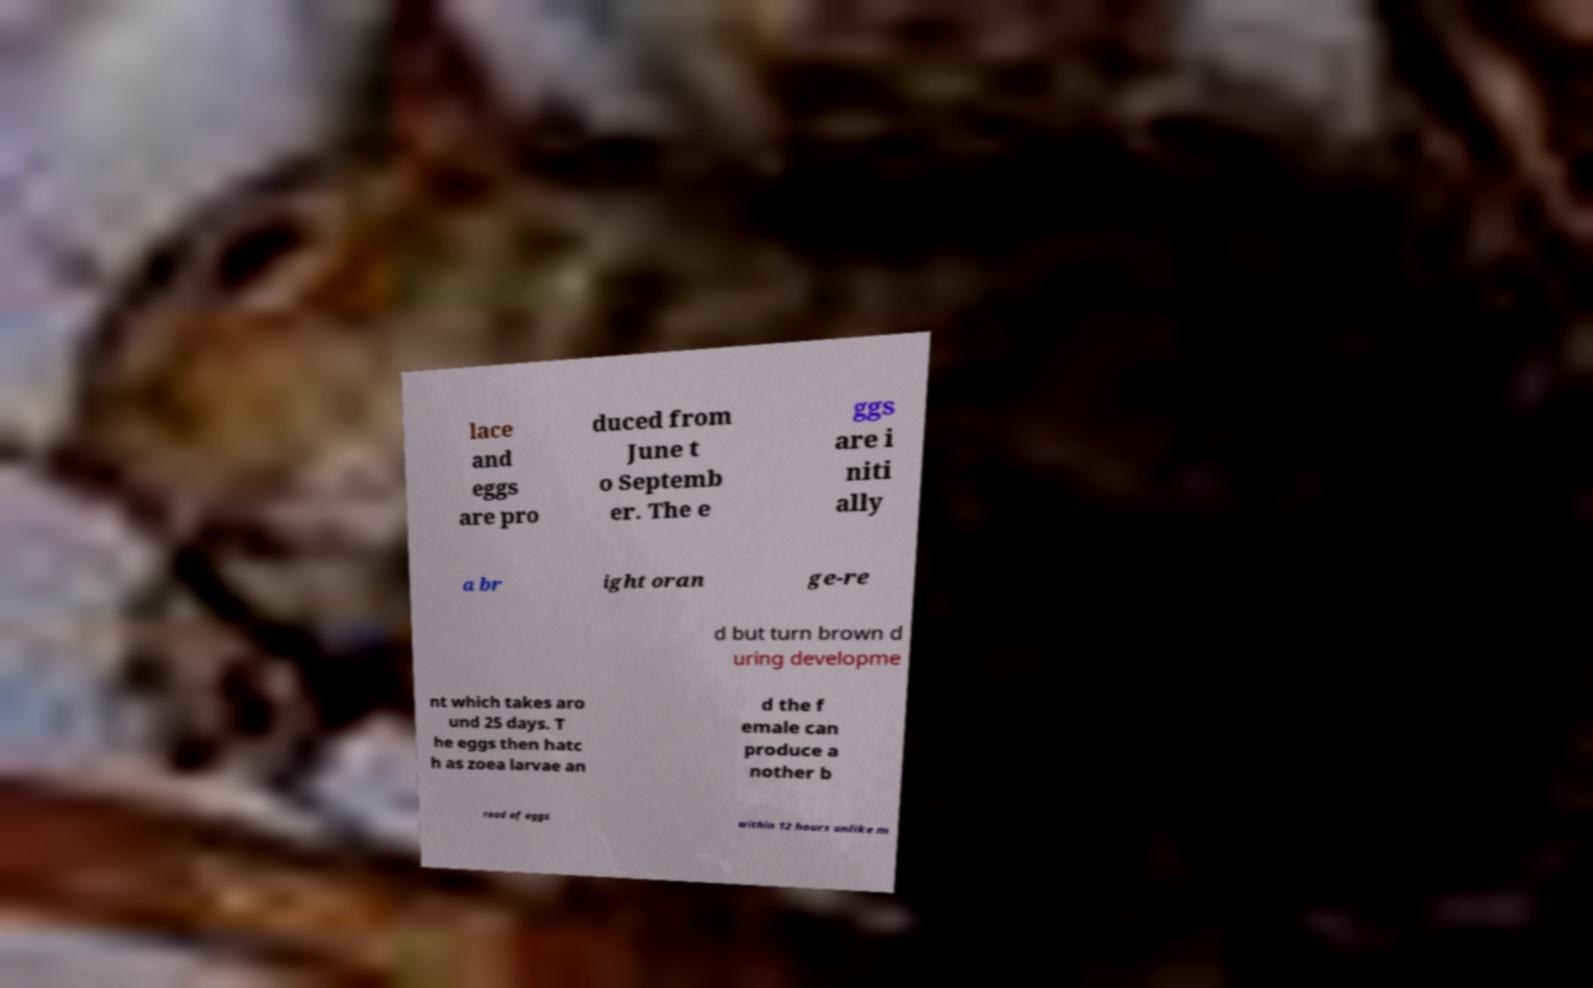Please identify and transcribe the text found in this image. lace and eggs are pro duced from June t o Septemb er. The e ggs are i niti ally a br ight oran ge-re d but turn brown d uring developme nt which takes aro und 25 days. T he eggs then hatc h as zoea larvae an d the f emale can produce a nother b rood of eggs within 12 hours unlike m 